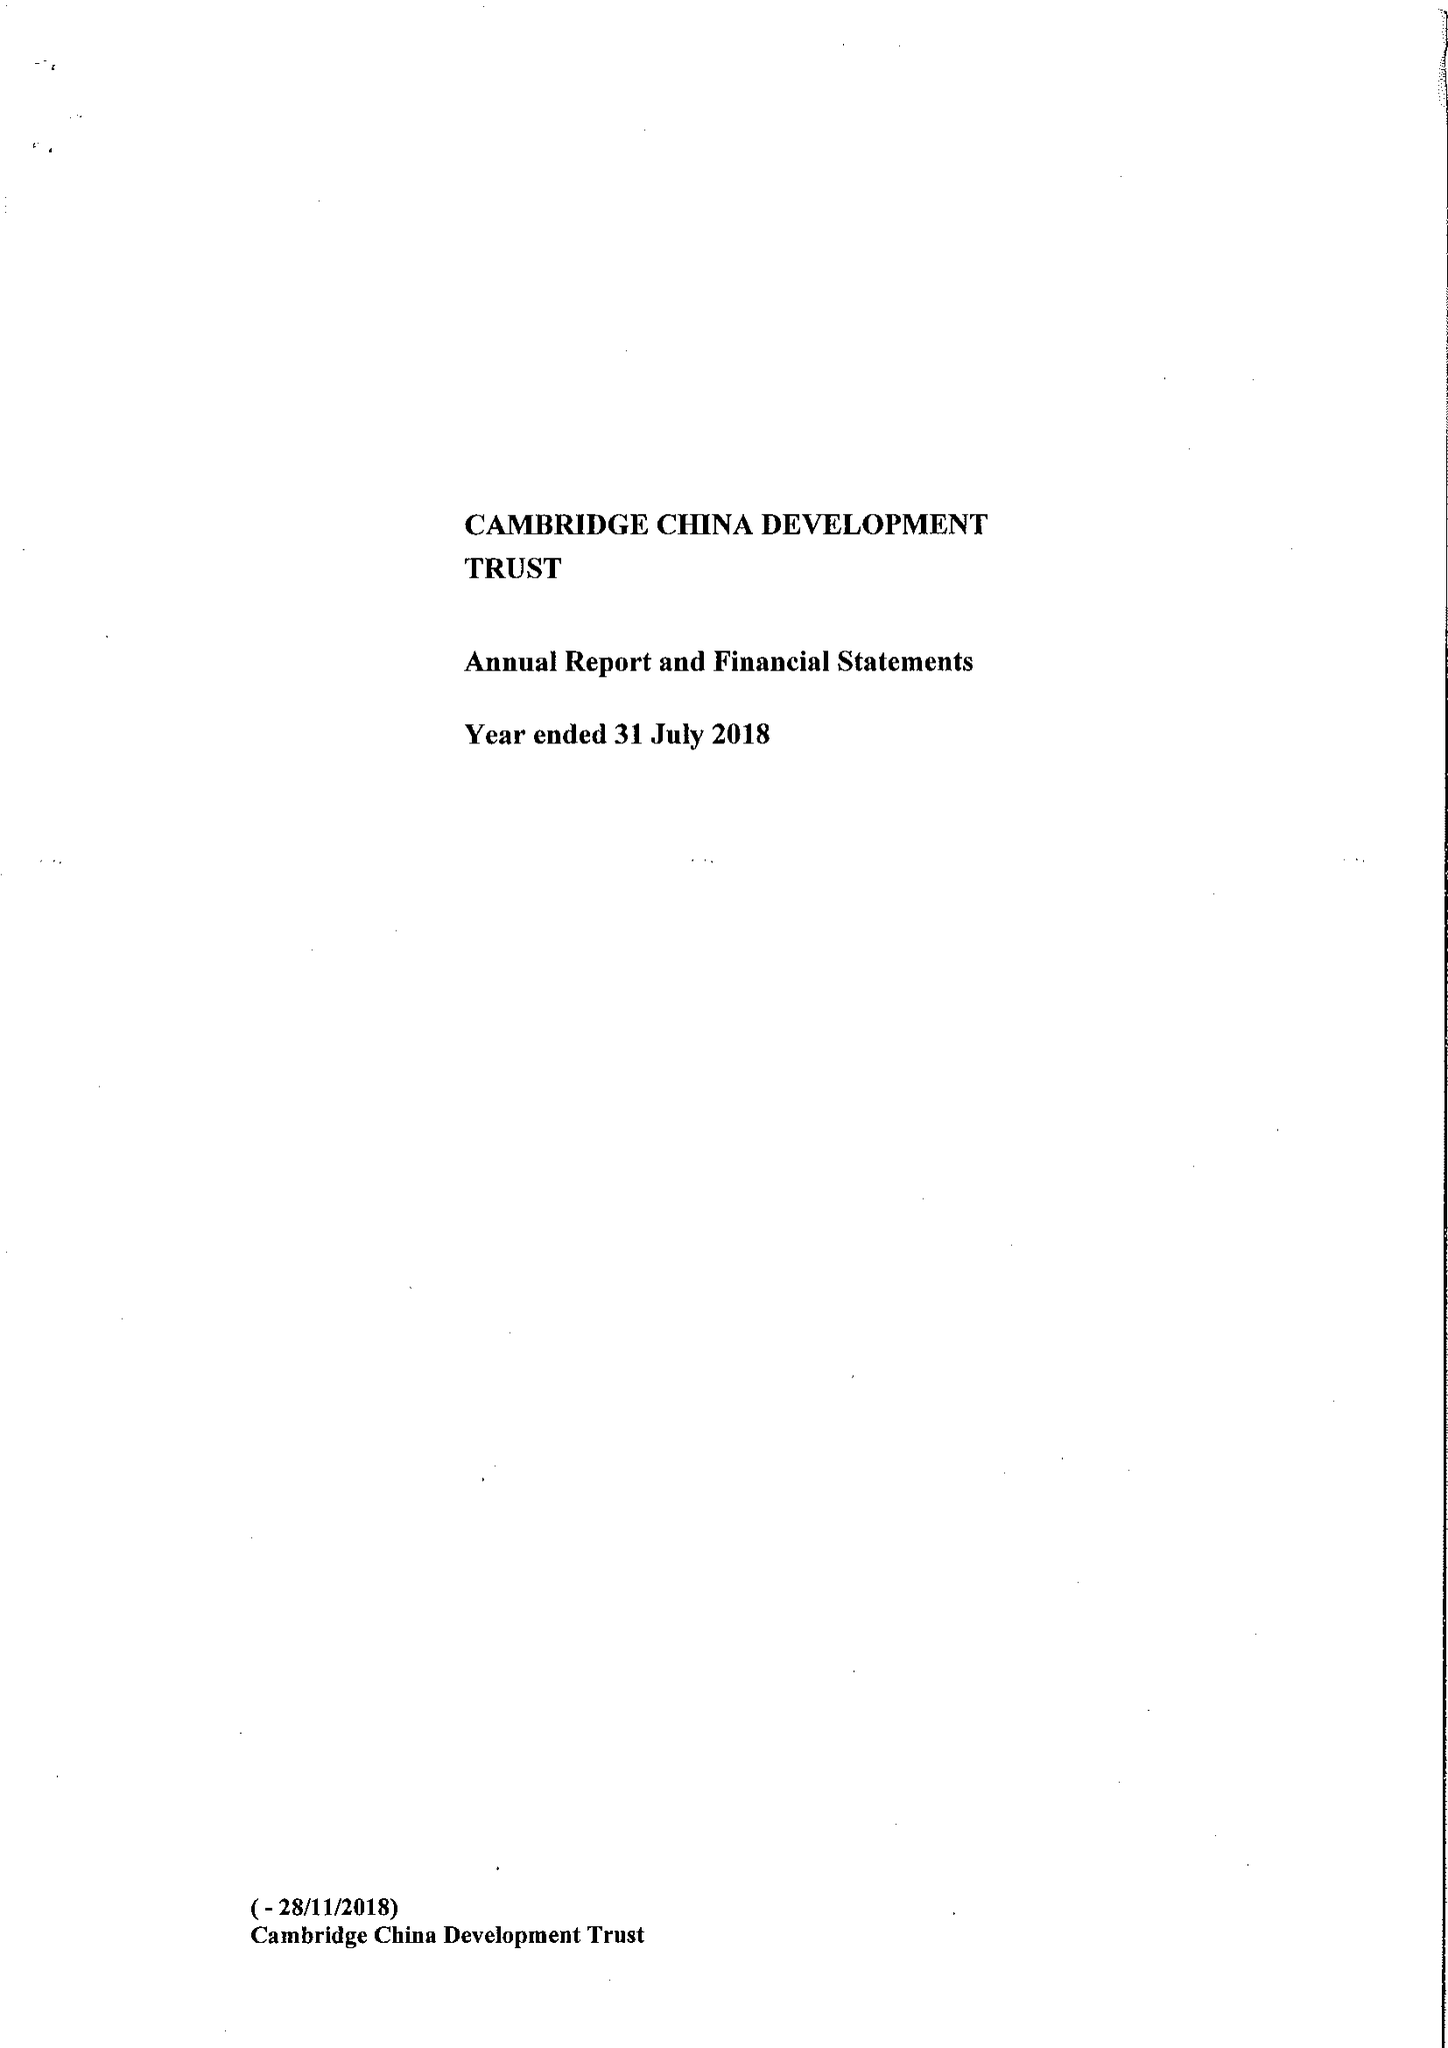What is the value for the report_date?
Answer the question using a single word or phrase. 2018-07-31 